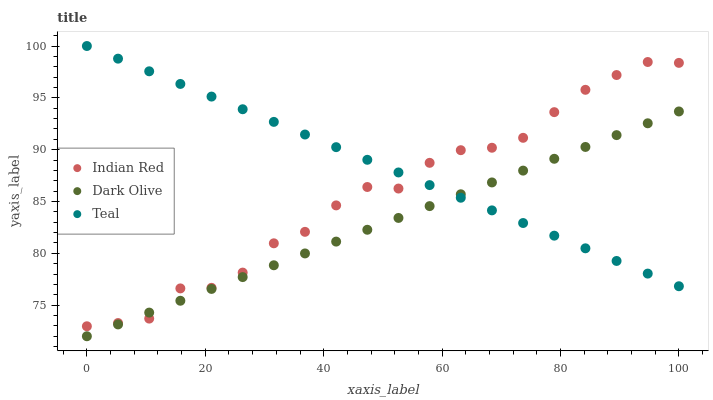Does Dark Olive have the minimum area under the curve?
Answer yes or no. Yes. Does Teal have the maximum area under the curve?
Answer yes or no. Yes. Does Indian Red have the minimum area under the curve?
Answer yes or no. No. Does Indian Red have the maximum area under the curve?
Answer yes or no. No. Is Dark Olive the smoothest?
Answer yes or no. Yes. Is Indian Red the roughest?
Answer yes or no. Yes. Is Teal the smoothest?
Answer yes or no. No. Is Teal the roughest?
Answer yes or no. No. Does Dark Olive have the lowest value?
Answer yes or no. Yes. Does Indian Red have the lowest value?
Answer yes or no. No. Does Teal have the highest value?
Answer yes or no. Yes. Does Indian Red have the highest value?
Answer yes or no. No. Does Teal intersect Indian Red?
Answer yes or no. Yes. Is Teal less than Indian Red?
Answer yes or no. No. Is Teal greater than Indian Red?
Answer yes or no. No. 